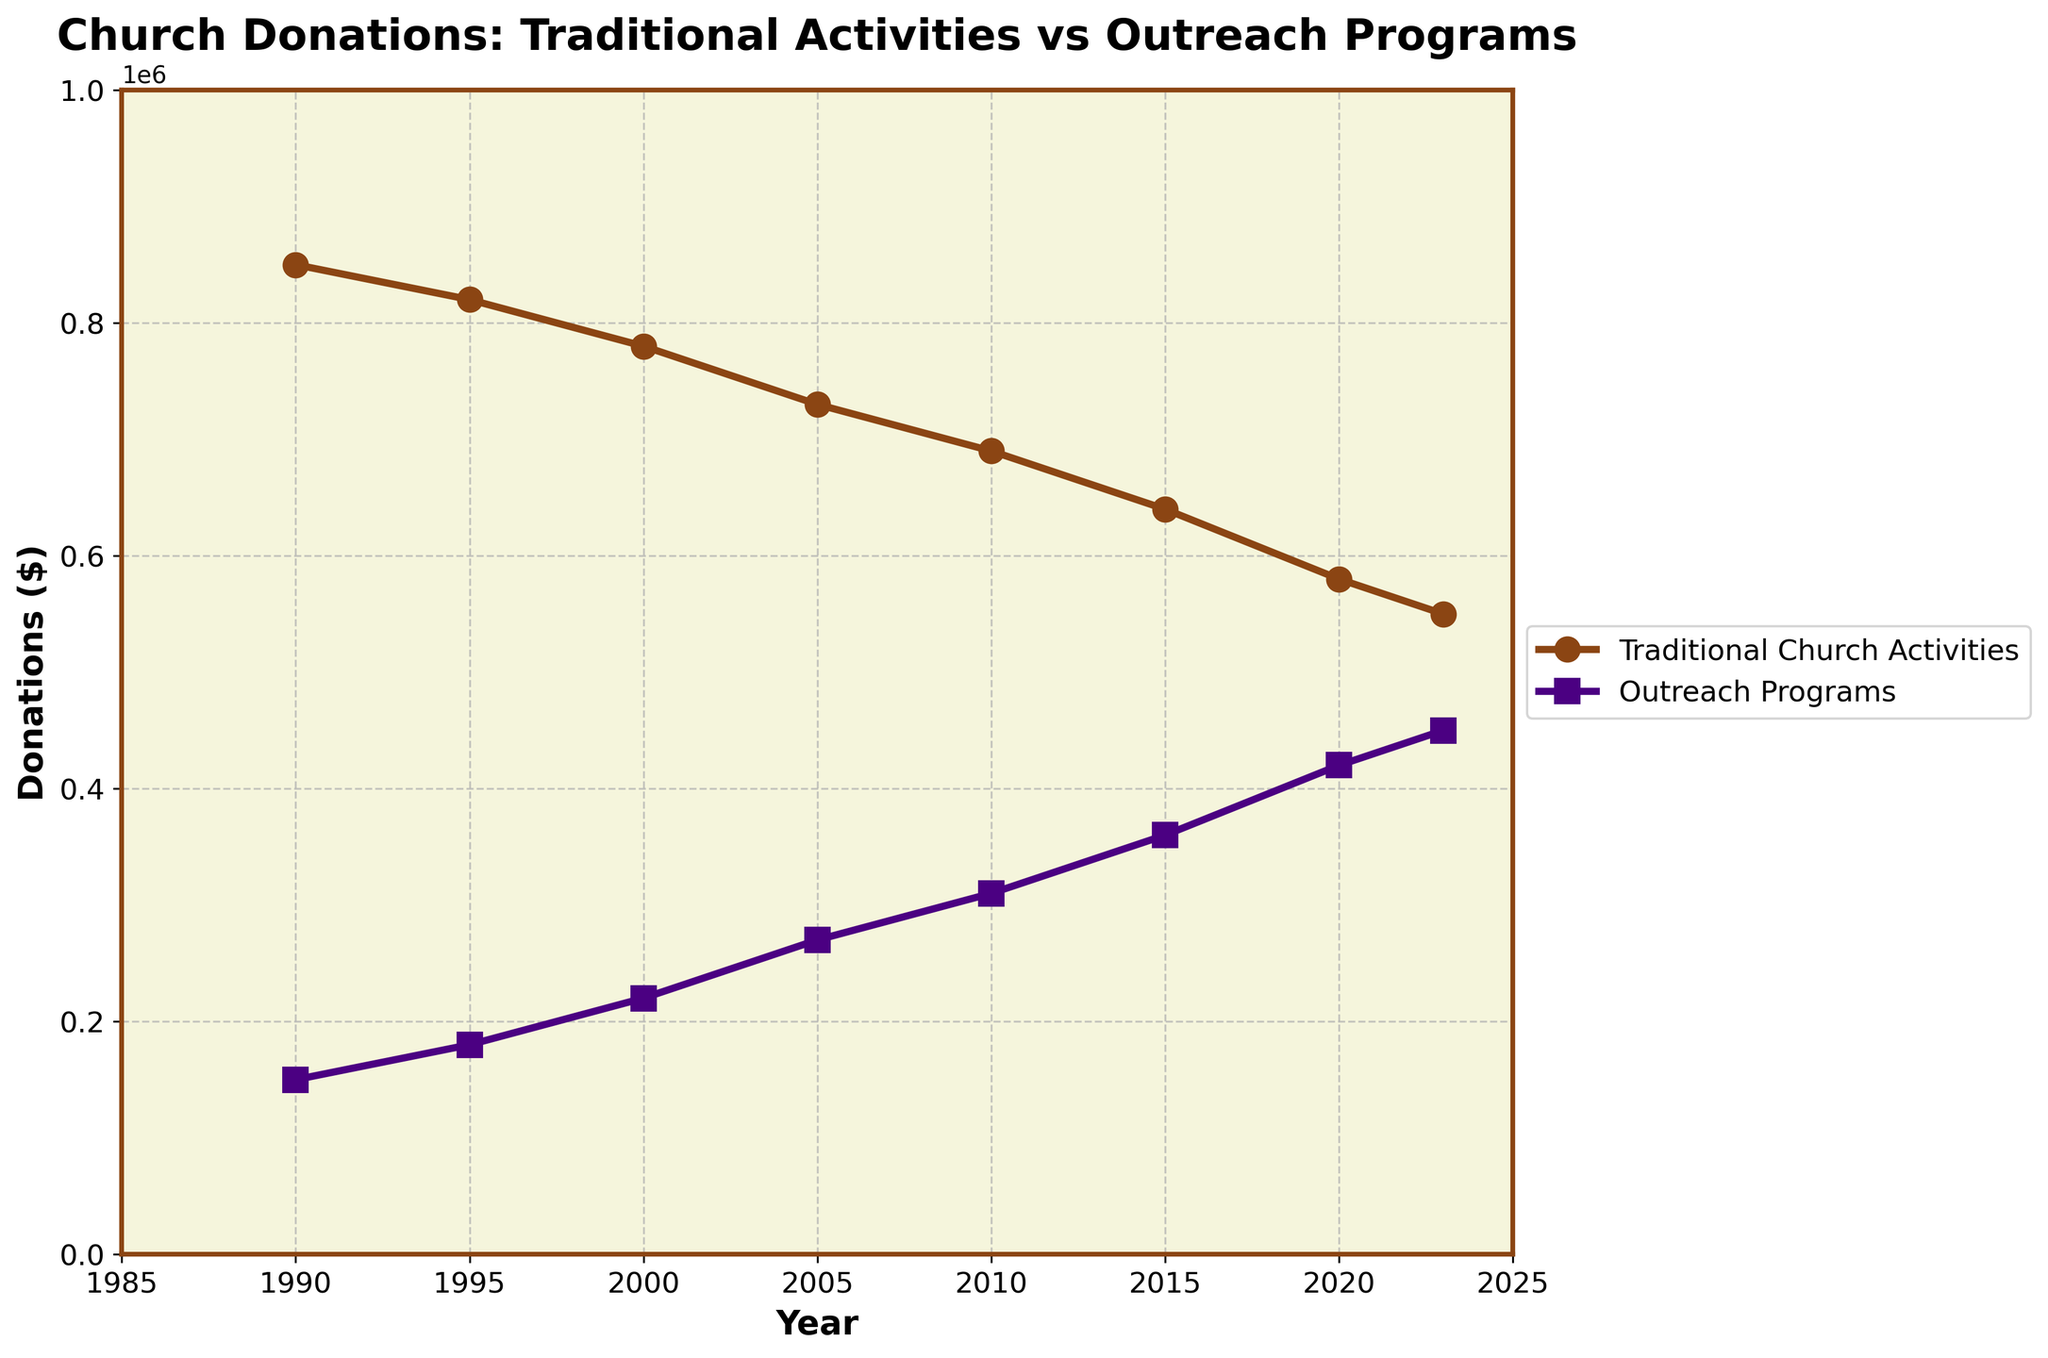What's the range of donations to Traditional Church Activities from 1990 to 2023? The range is the difference between the maximum and minimum values. From 1990 to 2023, donations to Traditional Church Activities range from 850,000 to 550,000. Therefore, the range is 850,000 - 550,000 = 300,000.
Answer: 300,000 In which year did Outreach Programs receive the same amount of donations as Traditional Church Activities in 2023? First, look at the donation amount for Traditional Church Activities in 2023, which is 550,000. Then, find the year in which Outreach Programs also received 550,000. A quick scan shows that no year matches this exact amount for Outreach Programs.
Answer: None By how much did donations to Outreach Programs increase from 1990 to 2023? Subtract the donation amount in 1990 from the amount in 2023 for Outreach Programs. That is 450,000 - 150,000 = 300,000.
Answer: 300,000 What is the overall trend in donations to Traditional Church Activities and Outreach Programs from 1990 to 2023? Traditional Church Activities show a decreasing trend, while Outreach Programs show an increasing trend from 1990 to 2023.
Answer: Decreasing for Traditional, Increasing for Outreach In which year did donations to Outreach Programs surpass 300,000? Locate the year on the plot where the Outreach Programs donations first exceed 300,000. This occurs in the year 2010.
Answer: 2010 What's the difference in donation amounts between Traditional Church Activities and Outreach Programs in 2020? Subtract the donation amount of Outreach Programs from Traditional Church Activities in 2020: 580,000 - 420,000 = 160,000.
Answer: 160,000 Compare the donation amounts to Traditional Church Activities and Outreach Programs in 1995. Which received more, and by how much? Look at the donation amounts in 1995: Traditional Church Activities received 820,000, and Outreach Programs received 180,000. The difference is 820,000 - 180,000 = 640,000. Traditional Church Activities received 640,000 more.
Answer: Traditional, by 640,000 How is the visual representation of Outreach Programs different from Traditional Church Activities on the plot? Outreach Programs are represented by a line with square markers and a purple color, while Traditional Church Activities are represented by a line with circular markers and a brown color.
Answer: Square markers in purple vs. circular markers in brown What's the average donation amount for Outreach Programs from 1990 to 2023? Add the donation amounts for Outreach Programs for all the given years and divide by the number of years: (150,000 + 180,000 + 220,000 + 270,000 + 310,000 + 360,000 + 420,000 + 450,000) / 8 = 2,360,000 / 8 = 295,000.
Answer: 295,000 